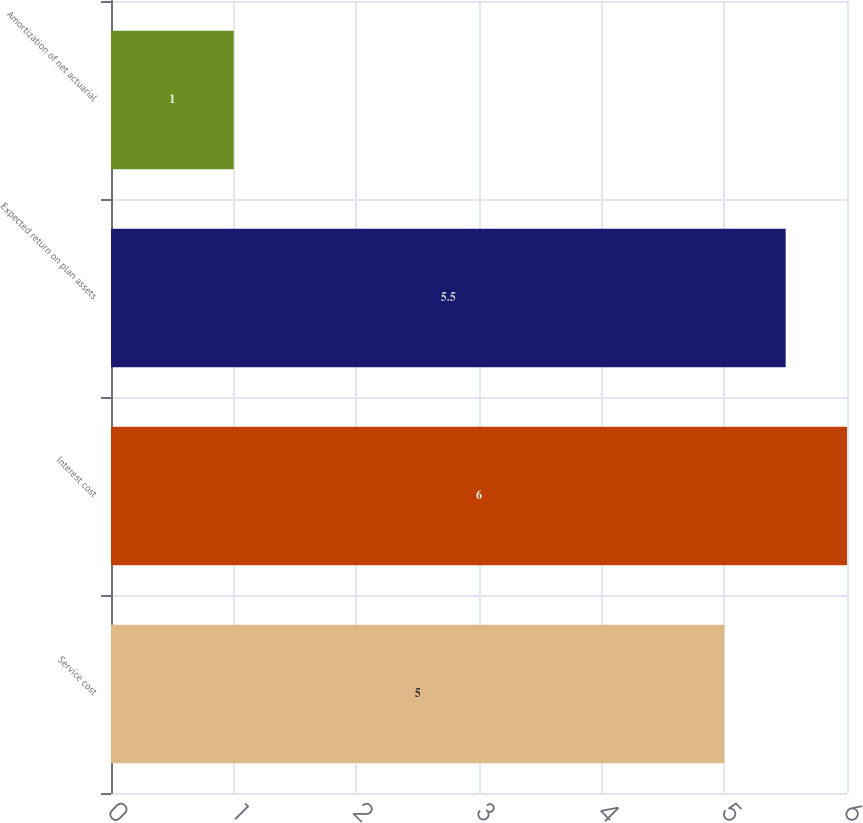Convert chart. <chart><loc_0><loc_0><loc_500><loc_500><bar_chart><fcel>Service cost<fcel>Interest cost<fcel>Expected return on plan assets<fcel>Amortization of net actuarial<nl><fcel>5<fcel>6<fcel>5.5<fcel>1<nl></chart> 